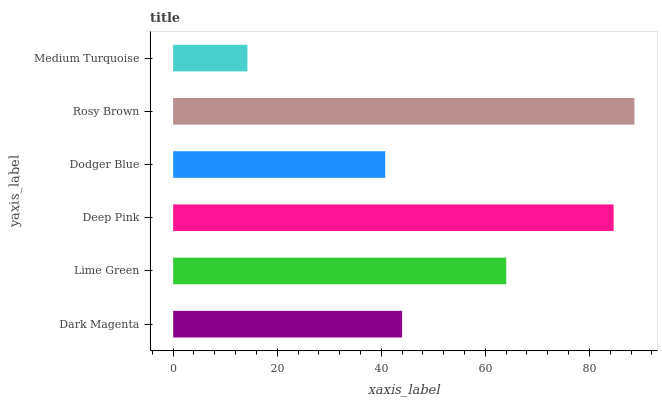Is Medium Turquoise the minimum?
Answer yes or no. Yes. Is Rosy Brown the maximum?
Answer yes or no. Yes. Is Lime Green the minimum?
Answer yes or no. No. Is Lime Green the maximum?
Answer yes or no. No. Is Lime Green greater than Dark Magenta?
Answer yes or no. Yes. Is Dark Magenta less than Lime Green?
Answer yes or no. Yes. Is Dark Magenta greater than Lime Green?
Answer yes or no. No. Is Lime Green less than Dark Magenta?
Answer yes or no. No. Is Lime Green the high median?
Answer yes or no. Yes. Is Dark Magenta the low median?
Answer yes or no. Yes. Is Dodger Blue the high median?
Answer yes or no. No. Is Medium Turquoise the low median?
Answer yes or no. No. 